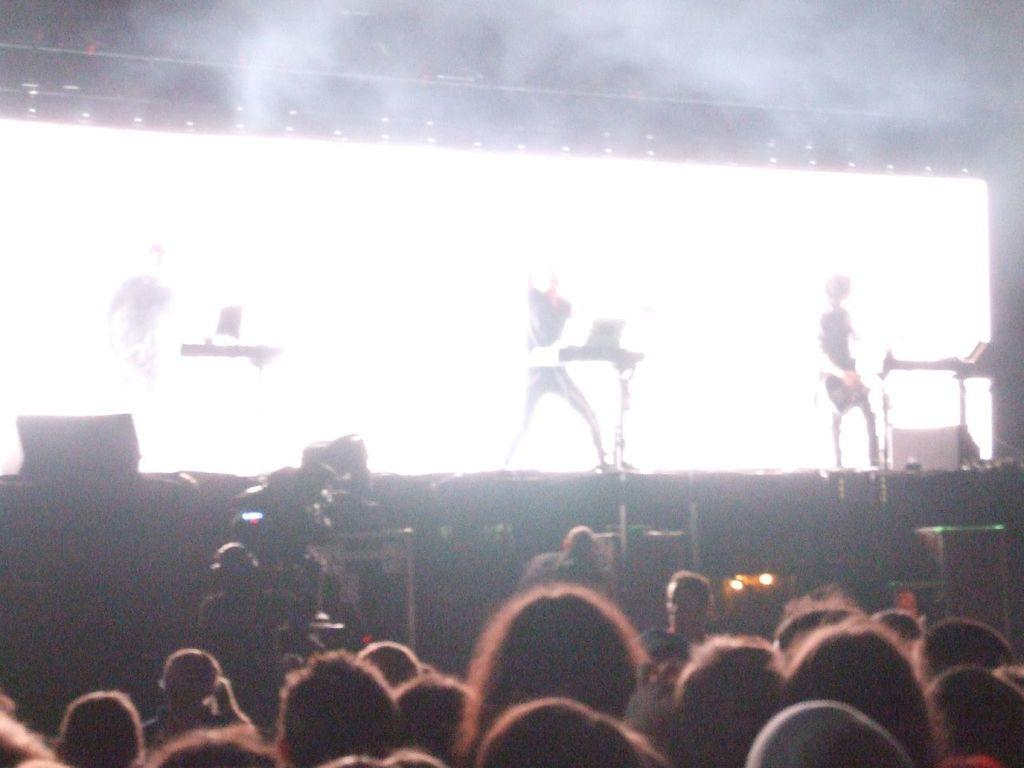What can be seen in the front of the image? There are persons in the front of the image. What is happening in the background of the image? There are musicians performing on a stage in the background. What objects are located in the center of the image? There are cameras in the center of the image. What is visible at the top of the image? There are lights visible at the top of the image. What type of air is being played by the musicians in the image? There is no air being played by the musicians in the image; they are performing on instruments. Can you provide an example of a specific instrument being played by the musicians in the image? The image does not provide enough detail to identify specific instruments being played by the musicians. 